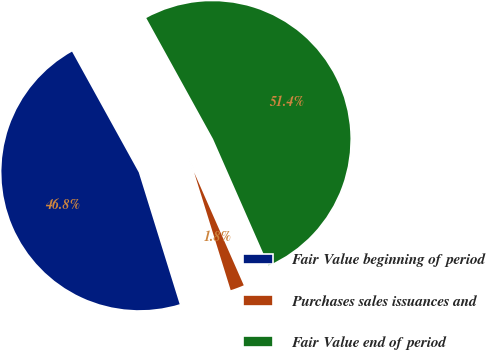Convert chart to OTSL. <chart><loc_0><loc_0><loc_500><loc_500><pie_chart><fcel>Fair Value beginning of period<fcel>Purchases sales issuances and<fcel>Fair Value end of period<nl><fcel>46.76%<fcel>1.8%<fcel>51.44%<nl></chart> 